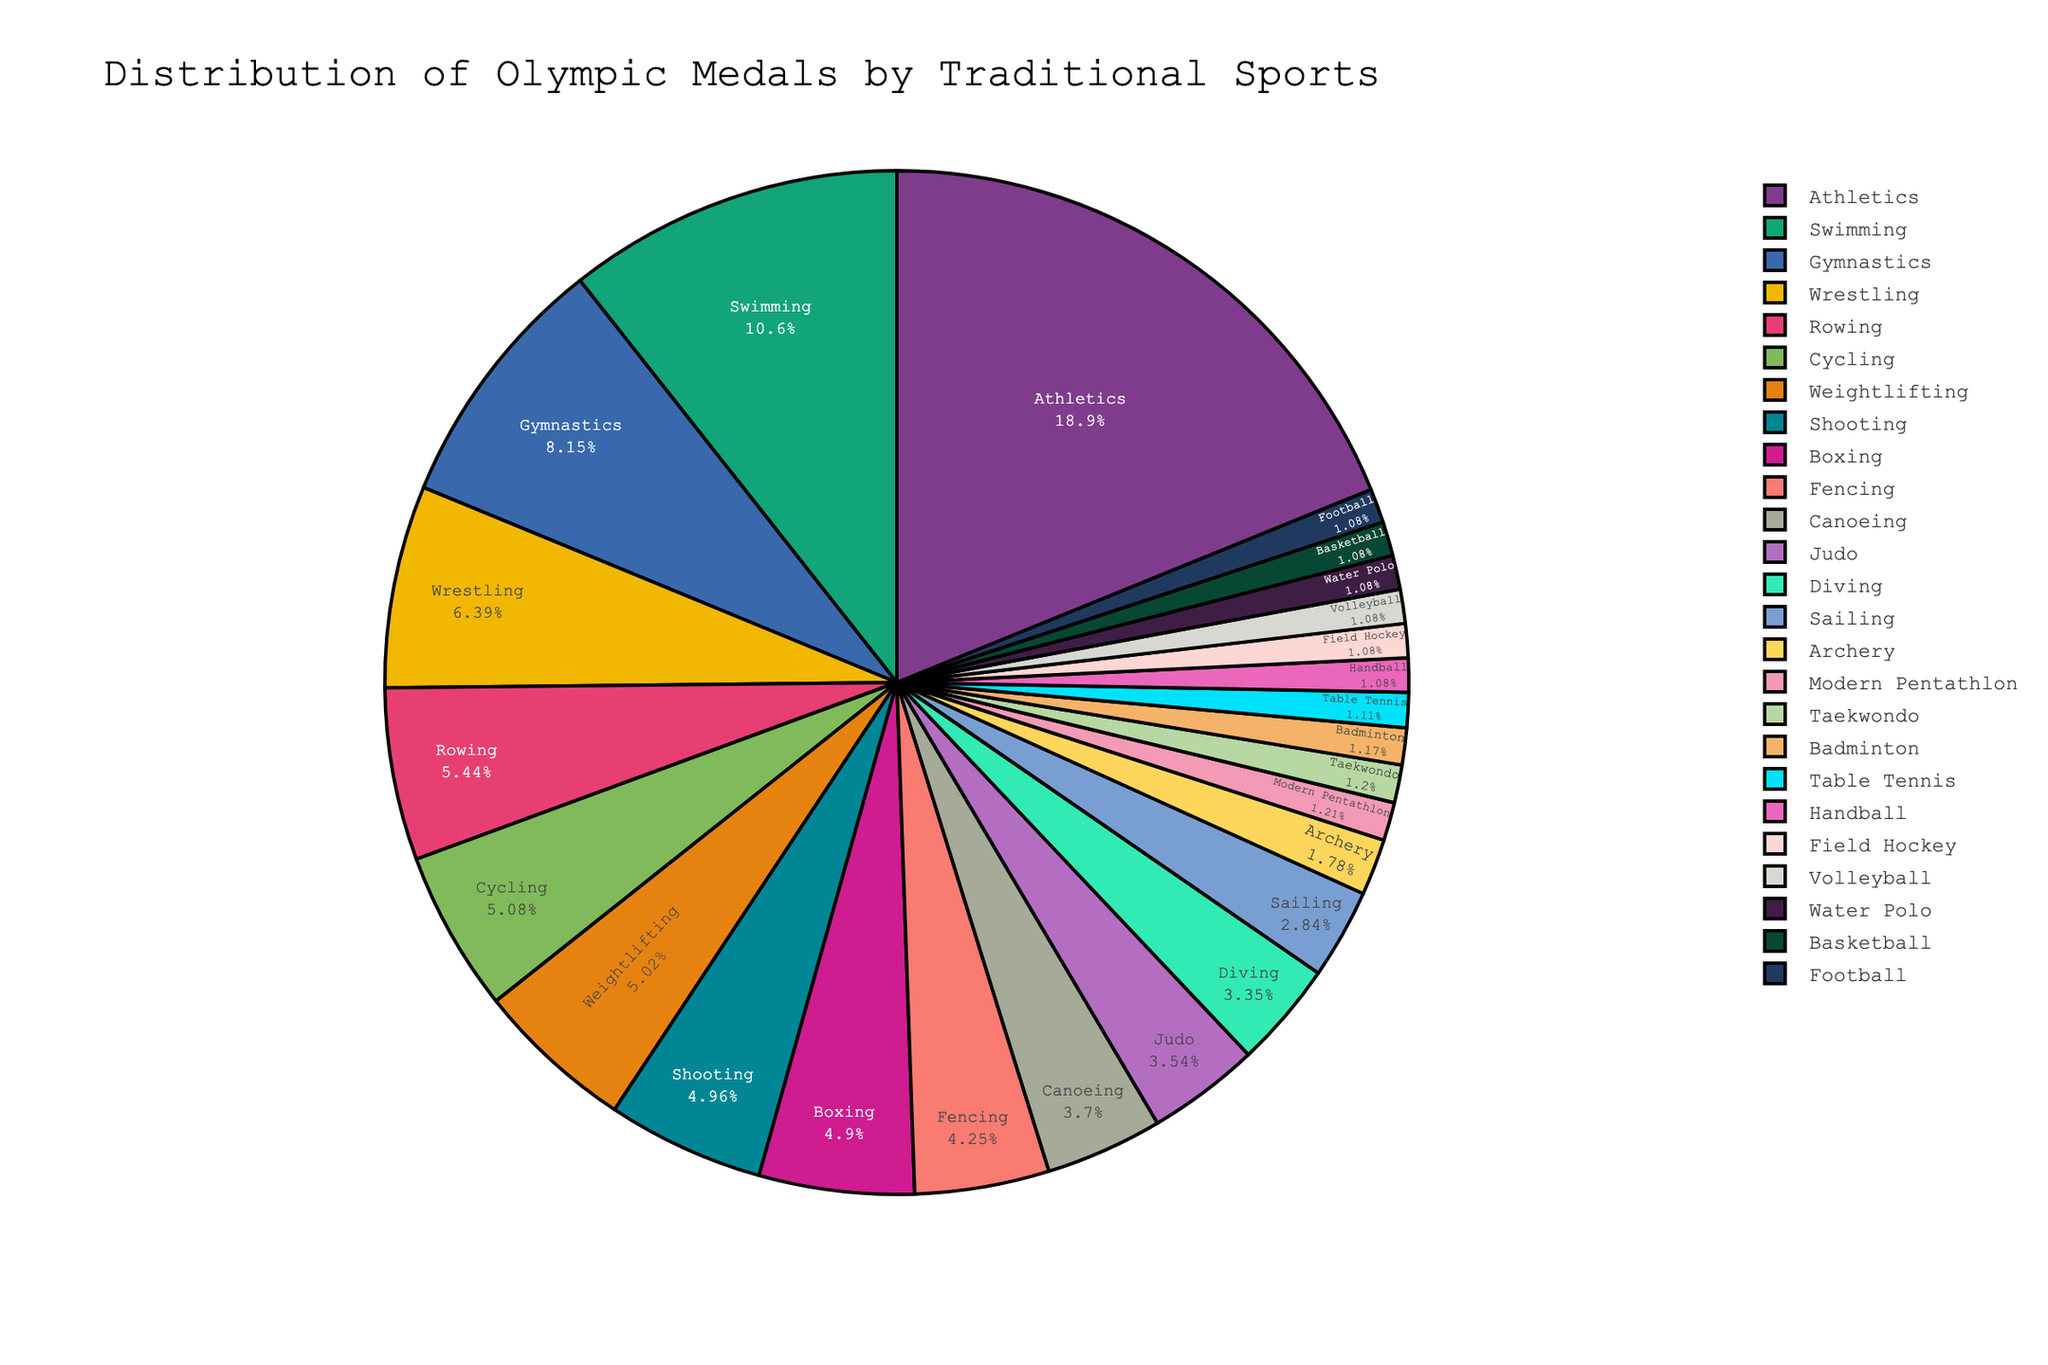what percentage of the total medals did Athletics win? To find this, look at the pie chart and find the segment for Athletics. The percentage should be labeled directly in that segment.
Answer: Athletics won approximately 33% of the total medals Which sport won more medals, Gymnastics or Wrestling? By comparing the labeled percentages or the section sizes within the pie chart, it's clear that Gymnastics has a larger section than Wrestling.
Answer: Gymnastics won more medals What's the difference in the number of medals won between Rowing and Cycling? First, check the pie chart for the individual medal counts for Rowing and Cycling. Rowing won 728 medals and Cycling won 680 medals. Subtract 680 from 728 to get the difference.
Answer: The difference is 48 medals Considering team sports only (Field Hockey, Handball, Volleyball, Water Polo, Basketball, Football), what is the total number of medals won? Identify and sum the medal counts from the pie chart for Field Hockey, Handball, Volleyball, Water Polo, Basketball, and Football. Each has won 144 medals. 144 * 6 = 864.
Answer: The total number of medals for team sports is 864 Which sport discipline has won the second-highest number of medals? Locate the largest segment first, which is Athletics, then find the second-largest segment in the pie chart. Swimming should be the second-largest segment after Athletics.
Answer: Swimming has won the second-highest number of medals Is the number of medals won by Judo greater than or equal to that of Shooting? Locate and compare the segments for Judo and Shooting in the pie chart. Shooting has won 663 medals, and Judo has won 474 medals. Clearly, Shooting won more.
Answer: No, the number of medals won by Judo is not greater than or equal to that of Shooting What sport accounts for the smallest segment of the pie chart, and what is the percentage? Look for the smallest segment in the pie chart. This smallest segment represents Modern Pentathlon. The percentage labeled on that segment will answer the question.
Answer: Modern Pentathlon, approximately 0.68% What is the combined percentage of medals won by Athletics and Swimming? Find the percentages for Athletics and Swimming segments. Athletics is around 33%, and Swimming is around 18.6%. Add those percentages. 33% + 18.6% = 51.6%.
Answer: The combined percentage is 51.6% Which has more medals, individual sports (Athletics, Swimming, Gymnastics) combined or team sports combined? First, sum up the medals for Athletics, Swimming, and Gymnastics: 2522 + 1421 + 1091 = 5034. Then, sum up the medals for team sports (Field Hockey, Handball, Volleyball, Water Polo, Basketball, Football): 144 * 6 = 864. Compare these totals. 5034 is clearly greater than 864.
Answer: Individual sports have more medals combined 